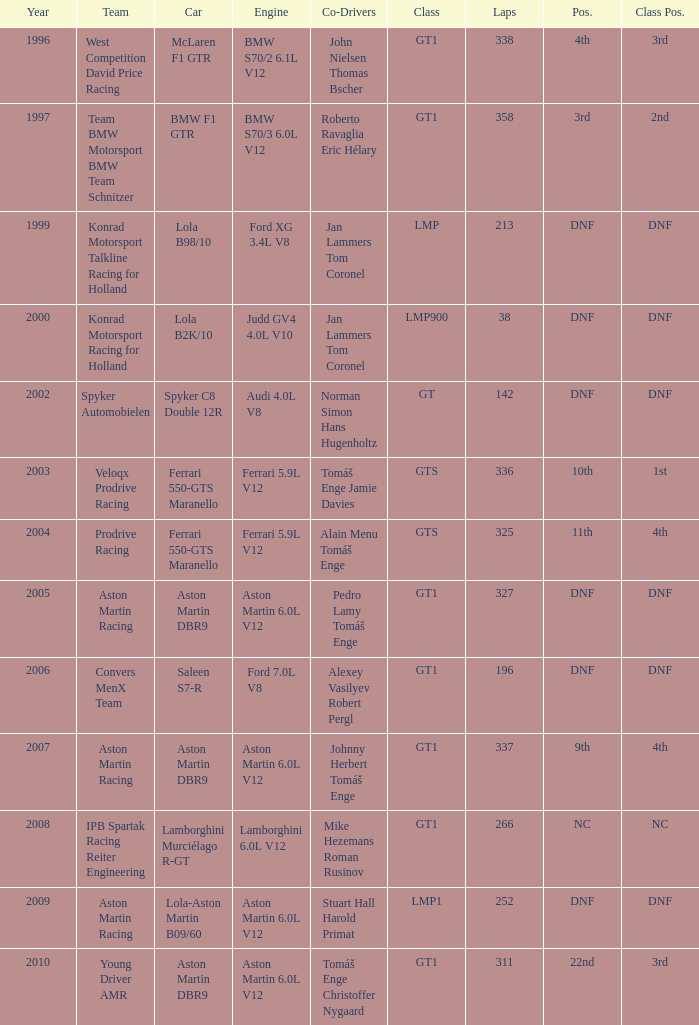In which class had 252 laps and a position of dnf? LMP1. 